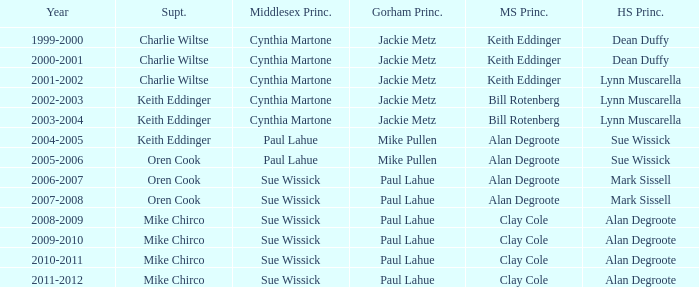Who were the superintendent(s) when the middle school principal was alan degroote, the gorham principal was paul lahue, and the year was 2006-2007? Oren Cook. 